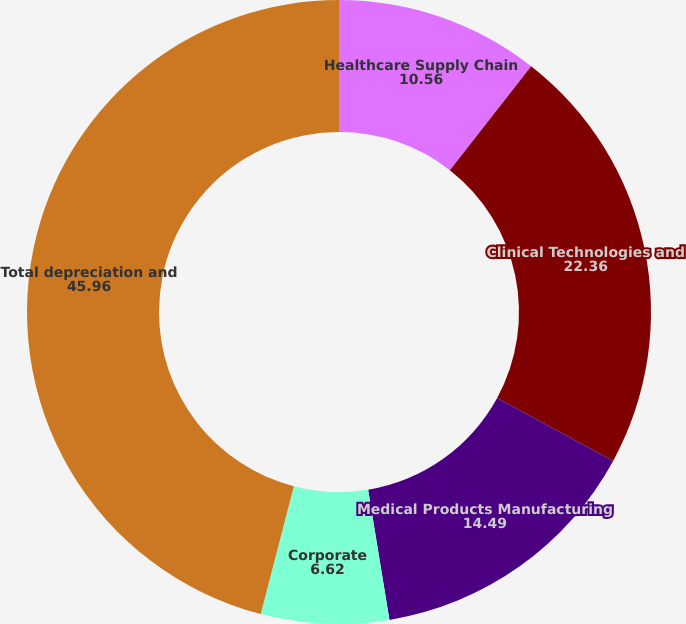Convert chart. <chart><loc_0><loc_0><loc_500><loc_500><pie_chart><fcel>Healthcare Supply Chain<fcel>Clinical Technologies and<fcel>Medical Products Manufacturing<fcel>Corporate<fcel>Total depreciation and<nl><fcel>10.56%<fcel>22.36%<fcel>14.49%<fcel>6.62%<fcel>45.96%<nl></chart> 